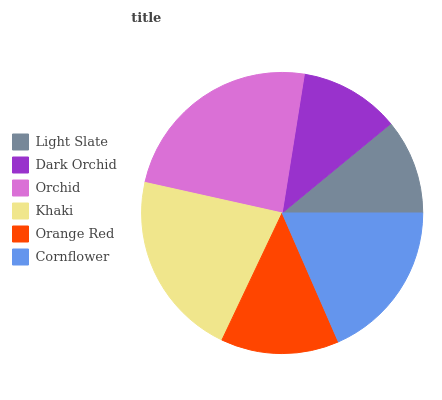Is Light Slate the minimum?
Answer yes or no. Yes. Is Orchid the maximum?
Answer yes or no. Yes. Is Dark Orchid the minimum?
Answer yes or no. No. Is Dark Orchid the maximum?
Answer yes or no. No. Is Dark Orchid greater than Light Slate?
Answer yes or no. Yes. Is Light Slate less than Dark Orchid?
Answer yes or no. Yes. Is Light Slate greater than Dark Orchid?
Answer yes or no. No. Is Dark Orchid less than Light Slate?
Answer yes or no. No. Is Cornflower the high median?
Answer yes or no. Yes. Is Orange Red the low median?
Answer yes or no. Yes. Is Light Slate the high median?
Answer yes or no. No. Is Dark Orchid the low median?
Answer yes or no. No. 